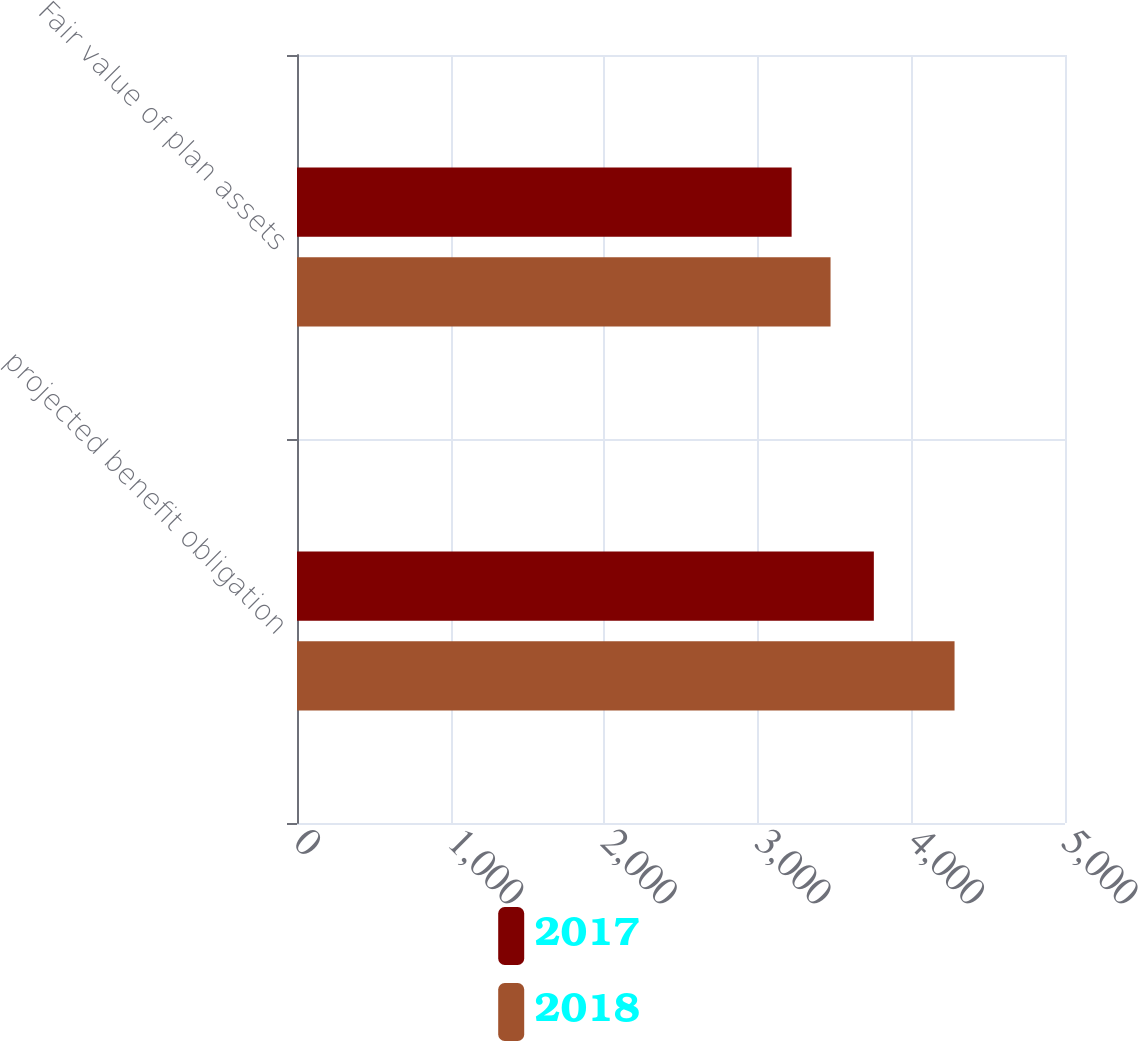Convert chart. <chart><loc_0><loc_0><loc_500><loc_500><stacked_bar_chart><ecel><fcel>projected benefit obligation<fcel>Fair value of plan assets<nl><fcel>2017<fcel>3755.5<fcel>3220.2<nl><fcel>2018<fcel>4280.9<fcel>3473.6<nl></chart> 